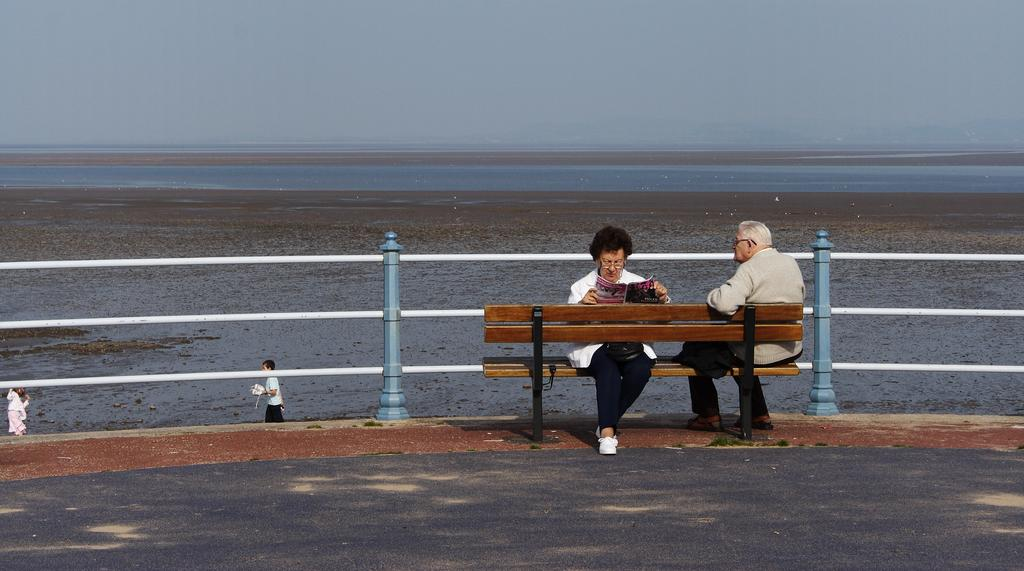Who are the two people seated on the bench in the image? There is a woman and a man seated on a bench in the image. What is the woman holding in the image? The woman is reading a magazine. What can be seen in the background of the image? There is water visible in a lake and a metal fence in the image. What are the two people walking doing in the image? There are two people walking, but their specific actions are not described in the provided facts. What type of house is visible in the pocket of the man in the image? There is no house visible in the pocket of the man in the image, as pockets are not large enough to contain houses. 